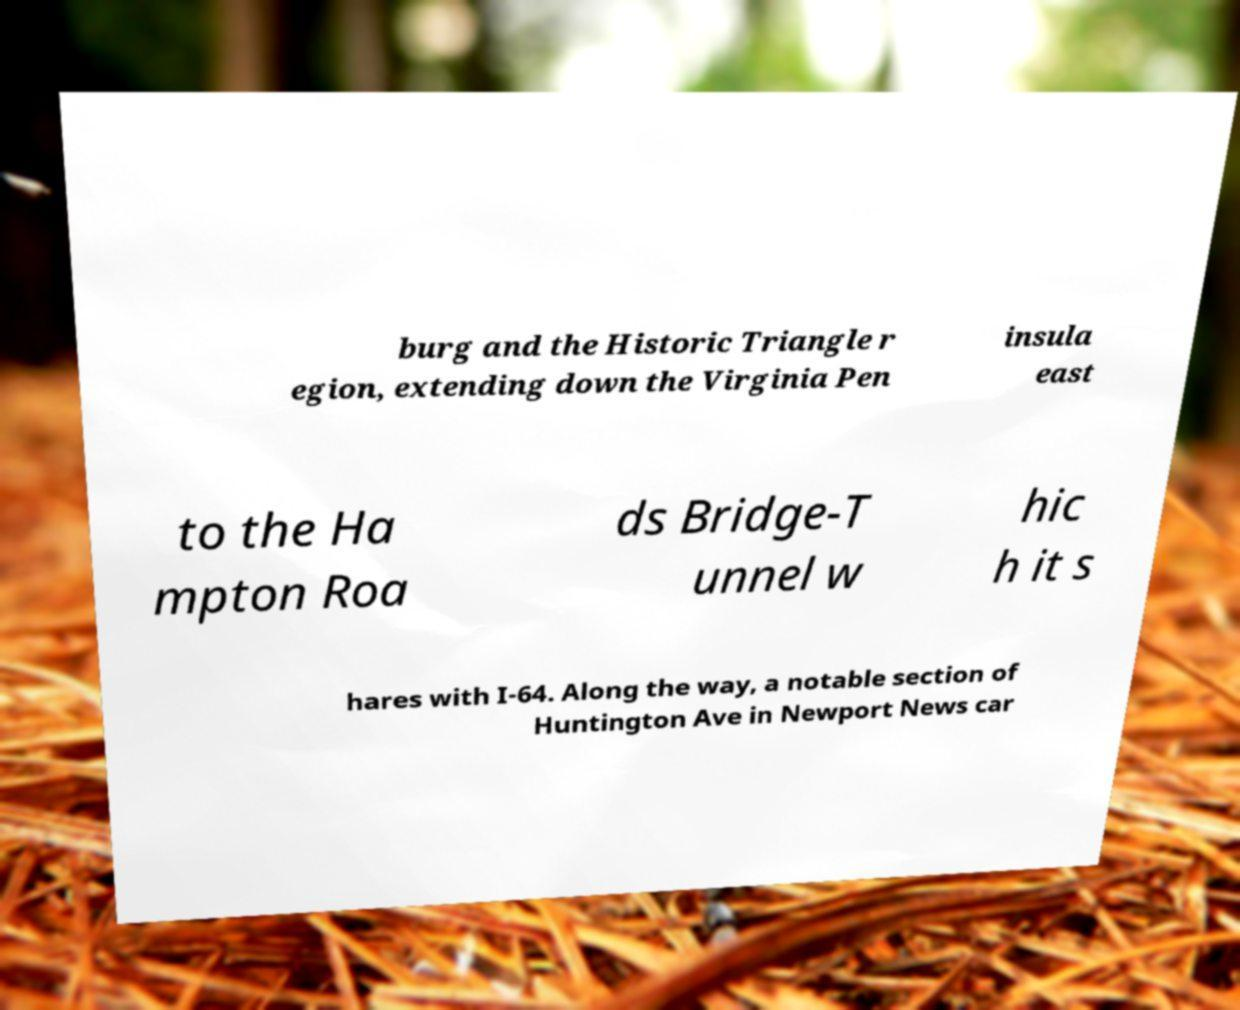For documentation purposes, I need the text within this image transcribed. Could you provide that? burg and the Historic Triangle r egion, extending down the Virginia Pen insula east to the Ha mpton Roa ds Bridge-T unnel w hic h it s hares with I-64. Along the way, a notable section of Huntington Ave in Newport News car 